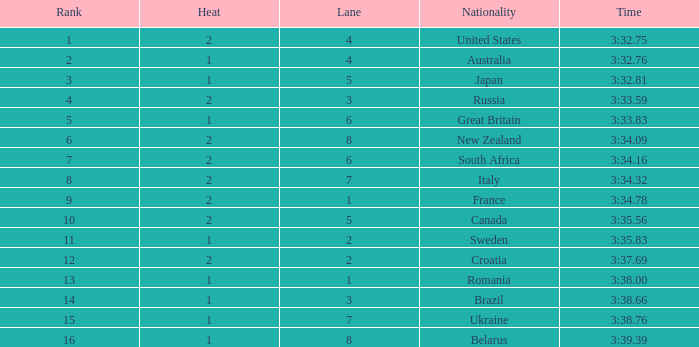What is the rank for lane 6 in heat 2? 7.0. 